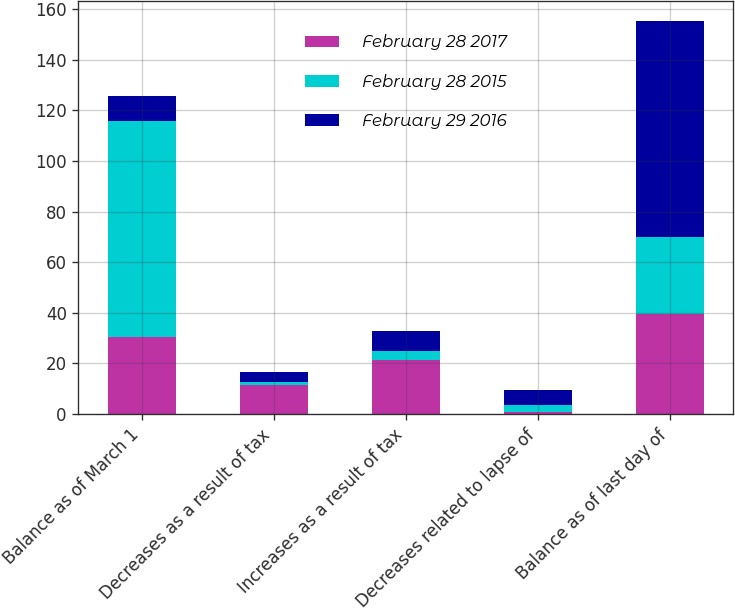<chart> <loc_0><loc_0><loc_500><loc_500><stacked_bar_chart><ecel><fcel>Balance as of March 1<fcel>Decreases as a result of tax<fcel>Increases as a result of tax<fcel>Decreases related to lapse of<fcel>Balance as of last day of<nl><fcel>February 28 2017<fcel>30.4<fcel>11.5<fcel>21.3<fcel>0.7<fcel>39.5<nl><fcel>February 28 2015<fcel>85.5<fcel>1.2<fcel>3.7<fcel>3<fcel>30.4<nl><fcel>February 29 2016<fcel>9.6<fcel>4<fcel>7.7<fcel>5.9<fcel>85.5<nl></chart> 